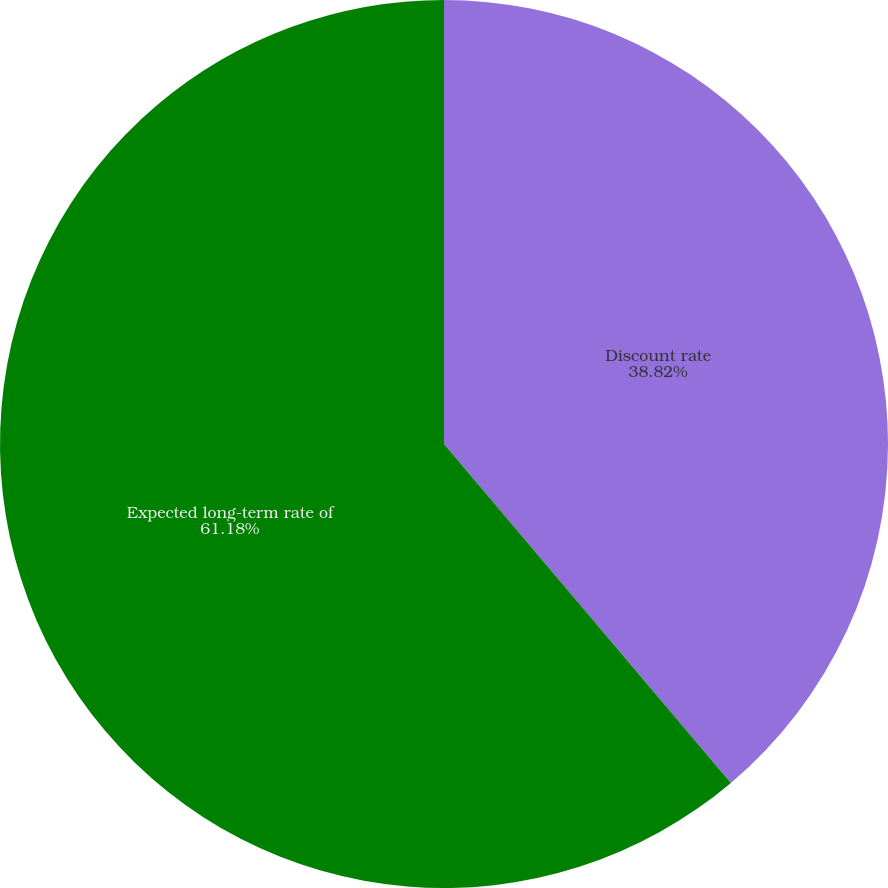Convert chart to OTSL. <chart><loc_0><loc_0><loc_500><loc_500><pie_chart><fcel>Discount rate<fcel>Expected long-term rate of<nl><fcel>38.82%<fcel>61.18%<nl></chart> 